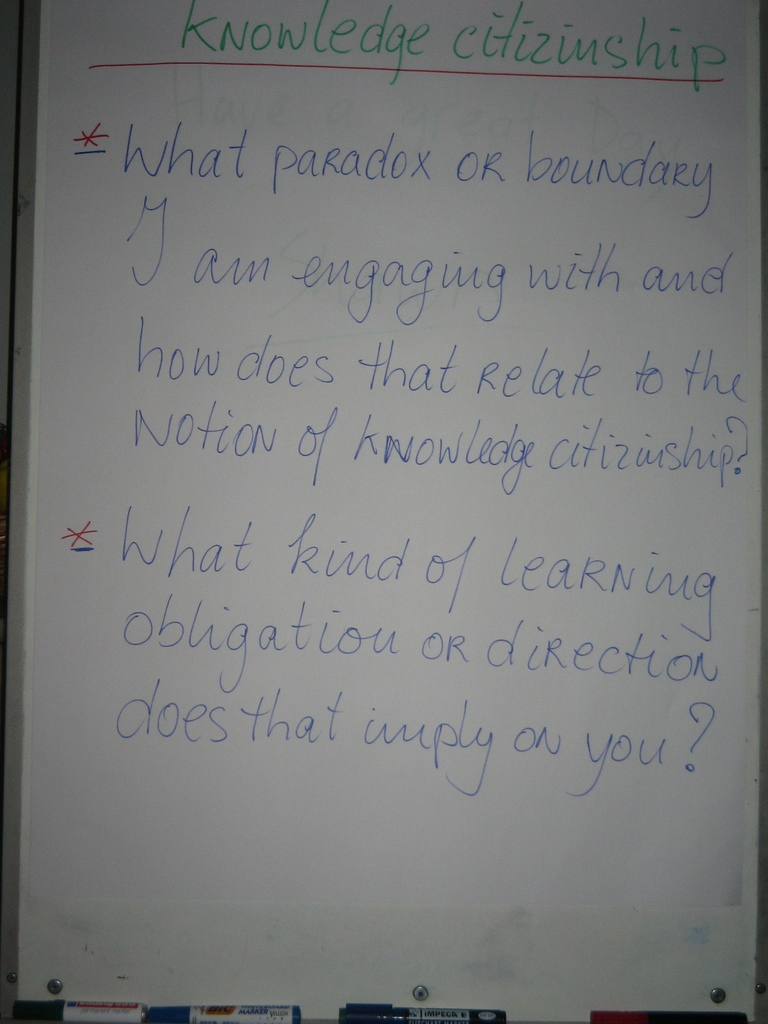What do you see happening in this image?
 The image presents a whiteboard with two thought-provoking questions written on it. The first question, penned in red, asks, "What paradox or boundary are you engaging with and how does that relate to the notion of knowledge citizenship?" This question prompts reflection on the challenges or contradictions one might be grappling with and how these experiences connect to the concept of being a responsible participant in the sharing and creation of knowledge.

The second question, written in black, inquires, "What kind of learning obligation or direction does that imply on you?" This question encourages introspection on the responsibilities or paths that these challenges or contradictions might suggest for one's learning journey. The two questions together seem to be guiding a discussion or exploration on the complexities of learning and knowledge sharing in a communal context. 